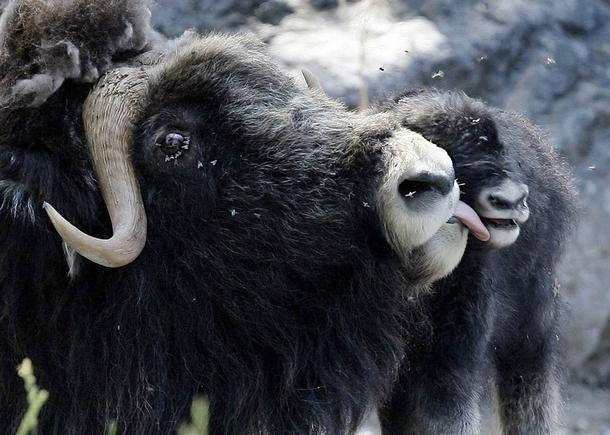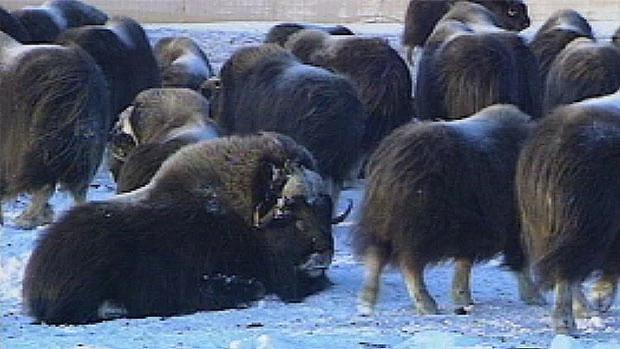The first image is the image on the left, the second image is the image on the right. Given the left and right images, does the statement "There are 8 or more buffalo present in the snow." hold true? Answer yes or no. Yes. The first image is the image on the left, the second image is the image on the right. Considering the images on both sides, is "In the left photo, there is only one buffalo." valid? Answer yes or no. No. 